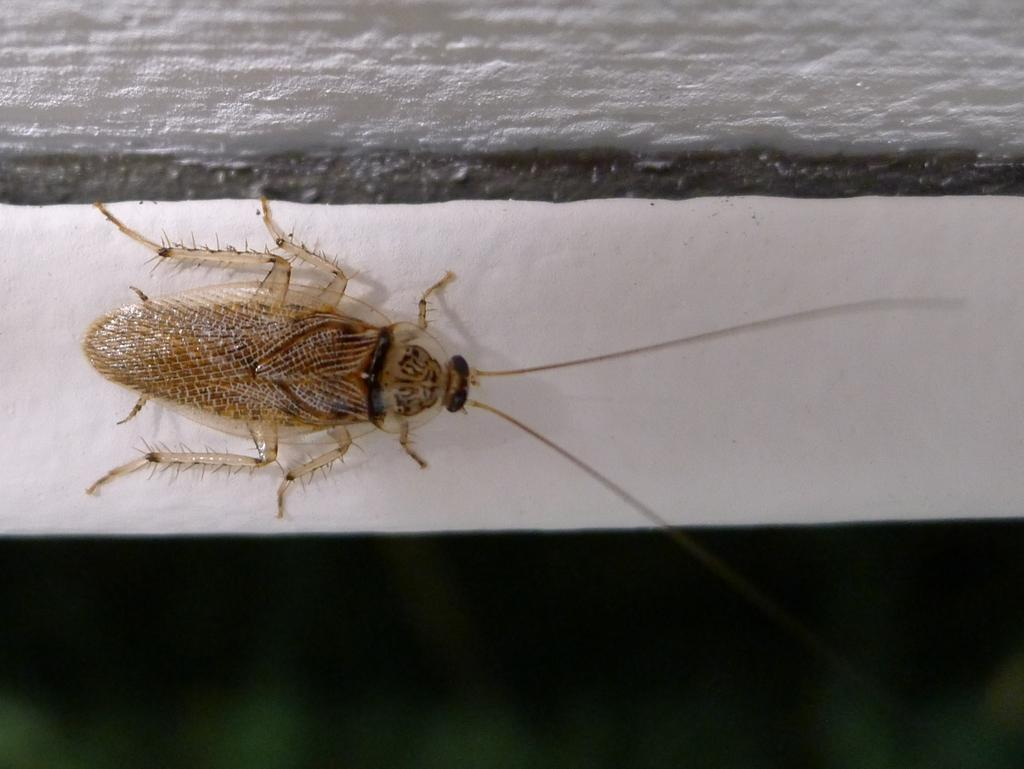What type of creature is present in the image? There is an insect in the image. Where is the insect located? The insect is on a white sheet. What type of sweater is the insect wearing in the image? There is no sweater present in the image, as insects do not wear clothing. 